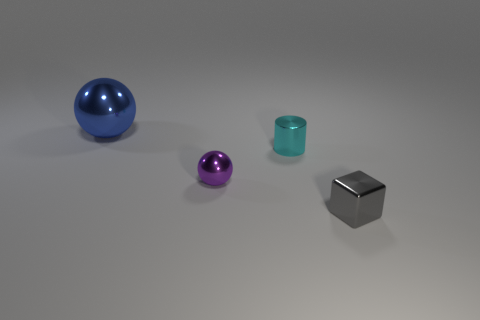Is the small ball made of the same material as the blue ball?
Give a very brief answer. Yes. How many purple things are either metal spheres or large metal things?
Offer a terse response. 1. Is the number of gray objects to the left of the big metal ball greater than the number of small cyan things?
Make the answer very short. No. Is there another metal ball of the same color as the tiny shiny sphere?
Make the answer very short. No. What is the size of the gray object?
Ensure brevity in your answer.  Small. Is the color of the large thing the same as the small metal cylinder?
Your answer should be very brief. No. How many things are big cyan cubes or metal spheres that are to the right of the big blue metal sphere?
Make the answer very short. 1. What number of metallic spheres are right of the shiny ball in front of the metal object that is to the left of the purple metal thing?
Your answer should be very brief. 0. How many brown metallic things are there?
Your answer should be compact. 0. There is a shiny cylinder behind the purple thing; does it have the same size as the large metal object?
Your answer should be compact. No. 